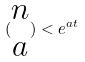<formula> <loc_0><loc_0><loc_500><loc_500>( \begin{matrix} n \\ a \end{matrix} ) < e ^ { a t }</formula> 